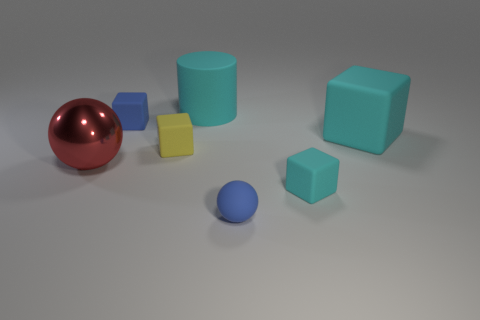The object that is the same color as the small sphere is what shape?
Offer a terse response. Cube. There is a cyan object behind the cube on the right side of the small cyan block; what is its size?
Give a very brief answer. Large. There is a large rubber cylinder; is its color the same as the large rubber object in front of the small blue matte block?
Your answer should be compact. Yes. Is the number of cyan rubber cubes on the left side of the cyan cylinder less than the number of cyan things?
Provide a short and direct response. Yes. How many other objects are there of the same size as the blue ball?
Ensure brevity in your answer.  3. Does the tiny blue object behind the large red object have the same shape as the yellow matte object?
Your response must be concise. Yes. Is the number of red things that are to the right of the tiny blue rubber cube greater than the number of large brown spheres?
Provide a short and direct response. No. There is a thing that is both behind the yellow matte block and right of the cyan cylinder; what material is it?
Offer a very short reply. Rubber. What number of rubber objects are both behind the small yellow matte object and in front of the big matte cylinder?
Your answer should be very brief. 2. What is the material of the big cyan cylinder?
Keep it short and to the point. Rubber. 